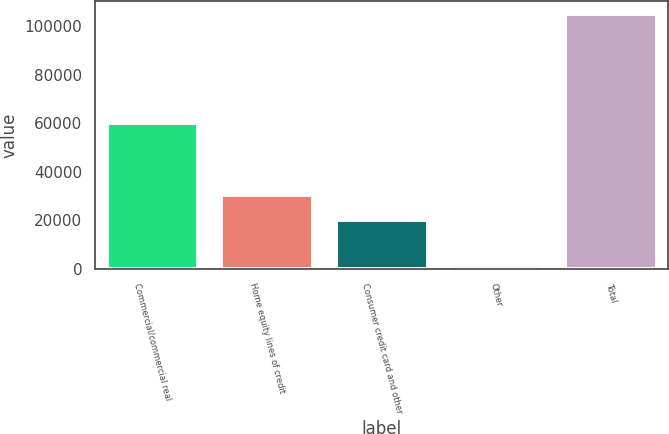<chart> <loc_0><loc_0><loc_500><loc_500><bar_chart><fcel>Commercial/commercial real<fcel>Home equity lines of credit<fcel>Consumer credit card and other<fcel>Other<fcel>Total<nl><fcel>60020<fcel>30549.2<fcel>20207<fcel>1466<fcel>104888<nl></chart> 